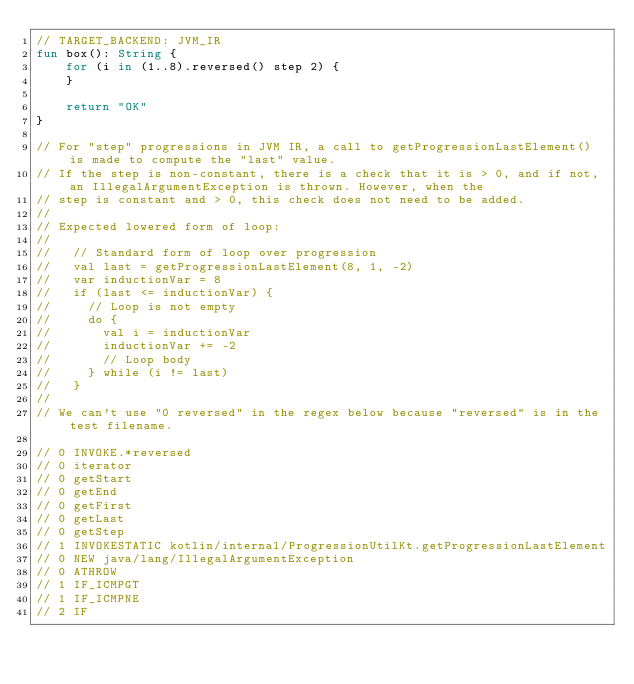Convert code to text. <code><loc_0><loc_0><loc_500><loc_500><_Kotlin_>// TARGET_BACKEND: JVM_IR
fun box(): String {
    for (i in (1..8).reversed() step 2) {
    }

    return "OK"
}

// For "step" progressions in JVM IR, a call to getProgressionLastElement() is made to compute the "last" value.
// If the step is non-constant, there is a check that it is > 0, and if not, an IllegalArgumentException is thrown. However, when the
// step is constant and > 0, this check does not need to be added.
//
// Expected lowered form of loop:
//
//   // Standard form of loop over progression
//   val last = getProgressionLastElement(8, 1, -2)
//   var inductionVar = 8
//   if (last <= inductionVar) {
//     // Loop is not empty
//     do {
//       val i = inductionVar
//       inductionVar += -2
//       // Loop body
//     } while (i != last)
//   }
//
// We can't use "0 reversed" in the regex below because "reversed" is in the test filename.

// 0 INVOKE.*reversed
// 0 iterator
// 0 getStart
// 0 getEnd
// 0 getFirst
// 0 getLast
// 0 getStep
// 1 INVOKESTATIC kotlin/internal/ProgressionUtilKt.getProgressionLastElement
// 0 NEW java/lang/IllegalArgumentException
// 0 ATHROW
// 1 IF_ICMPGT
// 1 IF_ICMPNE
// 2 IF</code> 